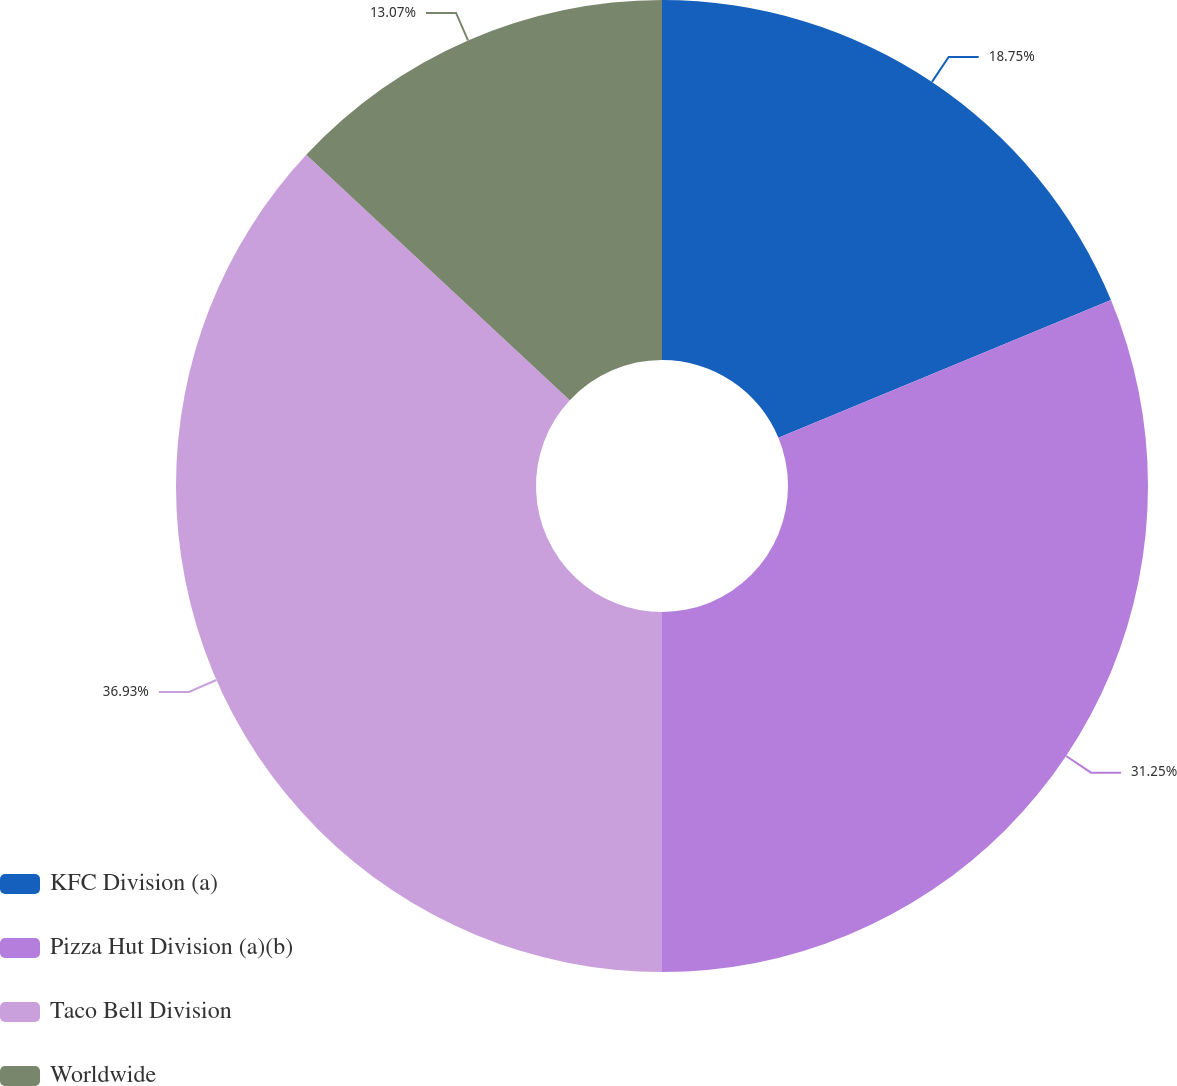Convert chart to OTSL. <chart><loc_0><loc_0><loc_500><loc_500><pie_chart><fcel>KFC Division (a)<fcel>Pizza Hut Division (a)(b)<fcel>Taco Bell Division<fcel>Worldwide<nl><fcel>18.75%<fcel>31.25%<fcel>36.93%<fcel>13.07%<nl></chart> 